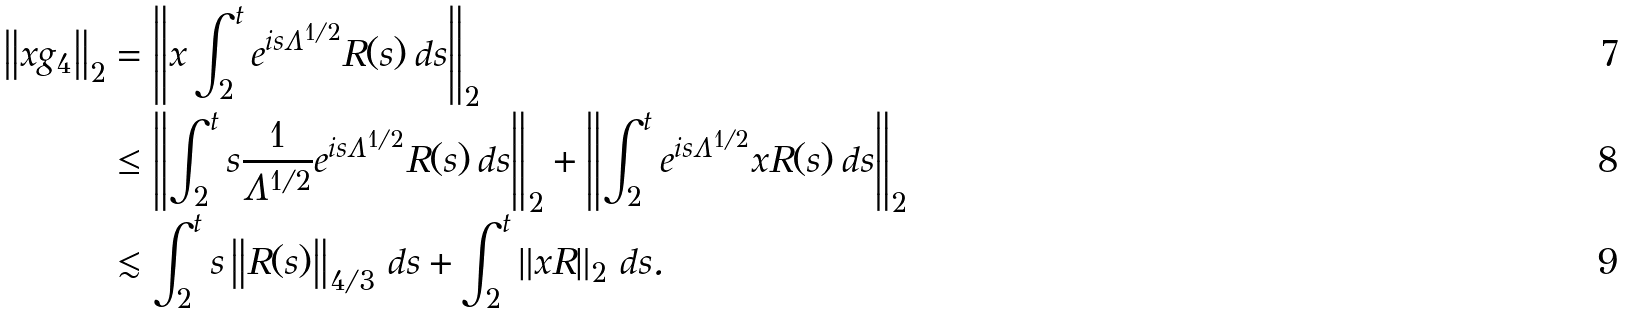Convert formula to latex. <formula><loc_0><loc_0><loc_500><loc_500>\left \| x g _ { 4 } \right \| _ { 2 } & = \left \| x \int _ { 2 } ^ { t } e ^ { i s \Lambda ^ { 1 / 2 } } R ( s ) \, d s \right \| _ { 2 } \\ & \leq \left \| \int _ { 2 } ^ { t } s \frac { 1 } { \Lambda ^ { 1 / 2 } } e ^ { i s \Lambda ^ { 1 / 2 } } R ( s ) \, d s \right \| _ { 2 } + \left \| \int _ { 2 } ^ { t } e ^ { i s \Lambda ^ { 1 / 2 } } x R ( s ) \, d s \right \| _ { 2 } \\ & \lesssim \int _ { 2 } ^ { t } s \left \| R ( s ) \right \| _ { 4 / 3 } \, d s + \int _ { 2 } ^ { t } \left \| x R \right \| _ { 2 } \, d s .</formula> 